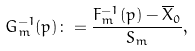<formula> <loc_0><loc_0><loc_500><loc_500>G _ { m } ^ { - 1 } ( p ) \colon = \frac { F _ { m } ^ { - 1 } ( p ) - \overline { X } _ { 0 } } { S _ { m } } ,</formula> 